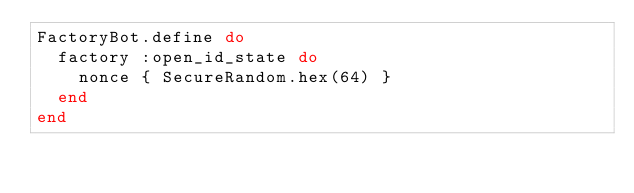Convert code to text. <code><loc_0><loc_0><loc_500><loc_500><_Ruby_>FactoryBot.define do
  factory :open_id_state do
    nonce { SecureRandom.hex(64) }
  end
end
</code> 